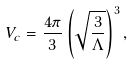Convert formula to latex. <formula><loc_0><loc_0><loc_500><loc_500>V _ { c } = \frac { 4 \pi } { 3 } \left ( \sqrt { \frac { 3 } { \Lambda } } \right ) ^ { 3 } ,</formula> 